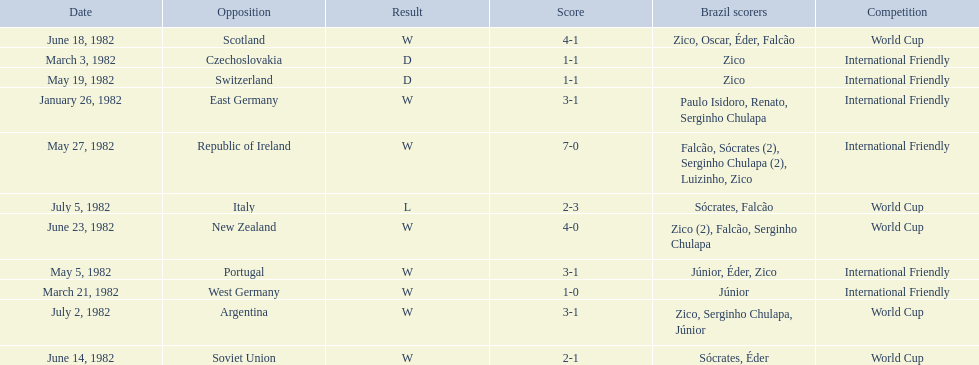How many times did brazil play west germany during the 1982 season? 1. 